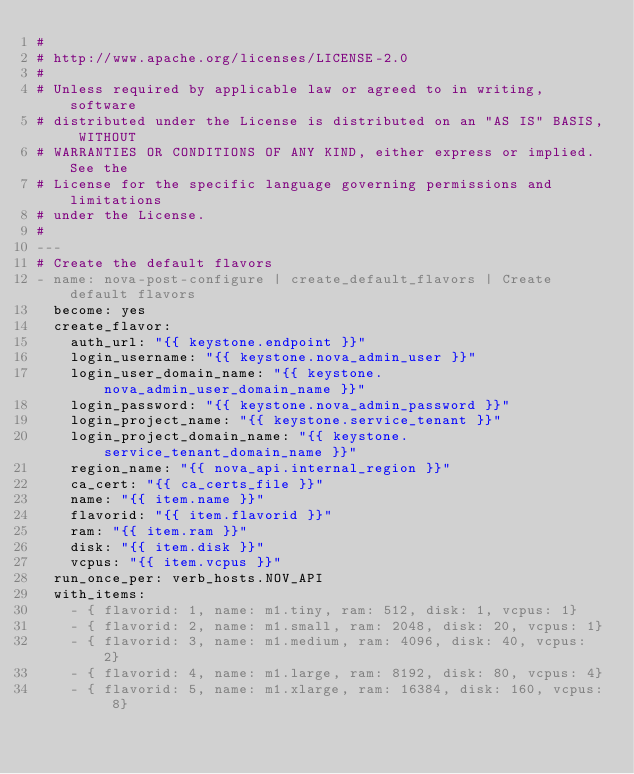<code> <loc_0><loc_0><loc_500><loc_500><_YAML_>#
# http://www.apache.org/licenses/LICENSE-2.0
#
# Unless required by applicable law or agreed to in writing, software
# distributed under the License is distributed on an "AS IS" BASIS, WITHOUT
# WARRANTIES OR CONDITIONS OF ANY KIND, either express or implied. See the
# License for the specific language governing permissions and limitations
# under the License.
#
---
# Create the default flavors
- name: nova-post-configure | create_default_flavors | Create default flavors
  become: yes
  create_flavor:
    auth_url: "{{ keystone.endpoint }}"
    login_username: "{{ keystone.nova_admin_user }}"
    login_user_domain_name: "{{ keystone.nova_admin_user_domain_name }}"
    login_password: "{{ keystone.nova_admin_password }}"
    login_project_name: "{{ keystone.service_tenant }}"
    login_project_domain_name: "{{ keystone.service_tenant_domain_name }}"
    region_name: "{{ nova_api.internal_region }}"
    ca_cert: "{{ ca_certs_file }}"
    name: "{{ item.name }}"
    flavorid: "{{ item.flavorid }}"
    ram: "{{ item.ram }}"
    disk: "{{ item.disk }}"
    vcpus: "{{ item.vcpus }}"
  run_once_per: verb_hosts.NOV_API
  with_items:
    - { flavorid: 1, name: m1.tiny, ram: 512, disk: 1, vcpus: 1}
    - { flavorid: 2, name: m1.small, ram: 2048, disk: 20, vcpus: 1}
    - { flavorid: 3, name: m1.medium, ram: 4096, disk: 40, vcpus: 2}
    - { flavorid: 4, name: m1.large, ram: 8192, disk: 80, vcpus: 4}
    - { flavorid: 5, name: m1.xlarge, ram: 16384, disk: 160, vcpus: 8}
</code> 